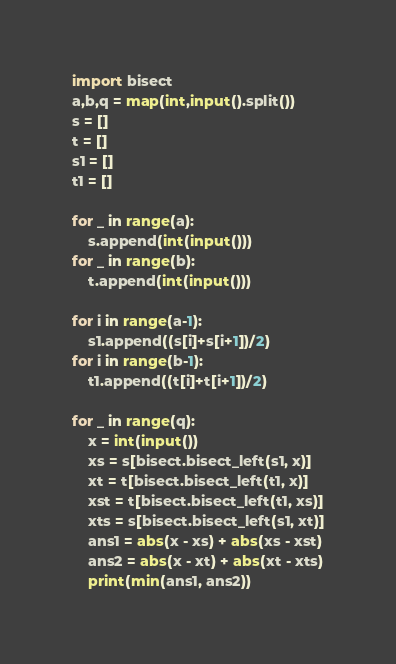<code> <loc_0><loc_0><loc_500><loc_500><_Python_>import bisect
a,b,q = map(int,input().split())
s = []
t = []
s1 = []
t1 = []

for _ in range(a):
    s.append(int(input()))
for _ in range(b):
    t.append(int(input()))

for i in range(a-1):
    s1.append((s[i]+s[i+1])/2)
for i in range(b-1):
    t1.append((t[i]+t[i+1])/2)

for _ in range(q):
    x = int(input())
    xs = s[bisect.bisect_left(s1, x)]
    xt = t[bisect.bisect_left(t1, x)]
    xst = t[bisect.bisect_left(t1, xs)]
    xts = s[bisect.bisect_left(s1, xt)]
    ans1 = abs(x - xs) + abs(xs - xst)
    ans2 = abs(x - xt) + abs(xt - xts)
    print(min(ans1, ans2))
</code> 